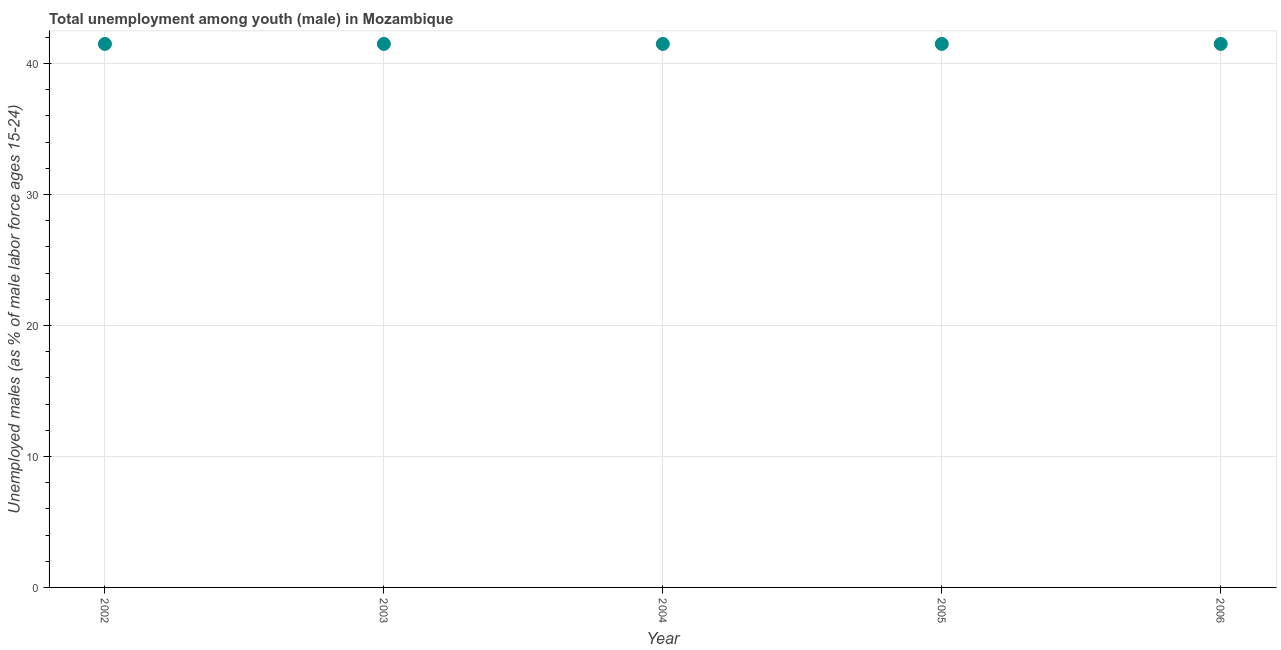What is the unemployed male youth population in 2006?
Offer a very short reply. 41.5. Across all years, what is the maximum unemployed male youth population?
Keep it short and to the point. 41.5. Across all years, what is the minimum unemployed male youth population?
Your answer should be very brief. 41.5. In which year was the unemployed male youth population minimum?
Offer a terse response. 2002. What is the sum of the unemployed male youth population?
Make the answer very short. 207.5. What is the difference between the unemployed male youth population in 2002 and 2003?
Make the answer very short. 0. What is the average unemployed male youth population per year?
Your answer should be very brief. 41.5. What is the median unemployed male youth population?
Your answer should be compact. 41.5. Do a majority of the years between 2002 and 2003 (inclusive) have unemployed male youth population greater than 10 %?
Keep it short and to the point. Yes. What is the ratio of the unemployed male youth population in 2003 to that in 2004?
Your response must be concise. 1. What is the difference between the highest and the second highest unemployed male youth population?
Provide a short and direct response. 0. Is the sum of the unemployed male youth population in 2003 and 2004 greater than the maximum unemployed male youth population across all years?
Give a very brief answer. Yes. How many dotlines are there?
Provide a short and direct response. 1. How many years are there in the graph?
Make the answer very short. 5. Are the values on the major ticks of Y-axis written in scientific E-notation?
Offer a terse response. No. Does the graph contain grids?
Offer a terse response. Yes. What is the title of the graph?
Offer a very short reply. Total unemployment among youth (male) in Mozambique. What is the label or title of the X-axis?
Give a very brief answer. Year. What is the label or title of the Y-axis?
Offer a terse response. Unemployed males (as % of male labor force ages 15-24). What is the Unemployed males (as % of male labor force ages 15-24) in 2002?
Make the answer very short. 41.5. What is the Unemployed males (as % of male labor force ages 15-24) in 2003?
Your response must be concise. 41.5. What is the Unemployed males (as % of male labor force ages 15-24) in 2004?
Offer a very short reply. 41.5. What is the Unemployed males (as % of male labor force ages 15-24) in 2005?
Provide a short and direct response. 41.5. What is the Unemployed males (as % of male labor force ages 15-24) in 2006?
Offer a terse response. 41.5. What is the difference between the Unemployed males (as % of male labor force ages 15-24) in 2002 and 2005?
Offer a very short reply. 0. What is the difference between the Unemployed males (as % of male labor force ages 15-24) in 2004 and 2005?
Offer a terse response. 0. What is the difference between the Unemployed males (as % of male labor force ages 15-24) in 2004 and 2006?
Offer a very short reply. 0. What is the ratio of the Unemployed males (as % of male labor force ages 15-24) in 2002 to that in 2004?
Offer a terse response. 1. What is the ratio of the Unemployed males (as % of male labor force ages 15-24) in 2002 to that in 2005?
Give a very brief answer. 1. What is the ratio of the Unemployed males (as % of male labor force ages 15-24) in 2002 to that in 2006?
Keep it short and to the point. 1. What is the ratio of the Unemployed males (as % of male labor force ages 15-24) in 2003 to that in 2004?
Make the answer very short. 1. What is the ratio of the Unemployed males (as % of male labor force ages 15-24) in 2004 to that in 2005?
Offer a very short reply. 1. What is the ratio of the Unemployed males (as % of male labor force ages 15-24) in 2004 to that in 2006?
Offer a terse response. 1. 